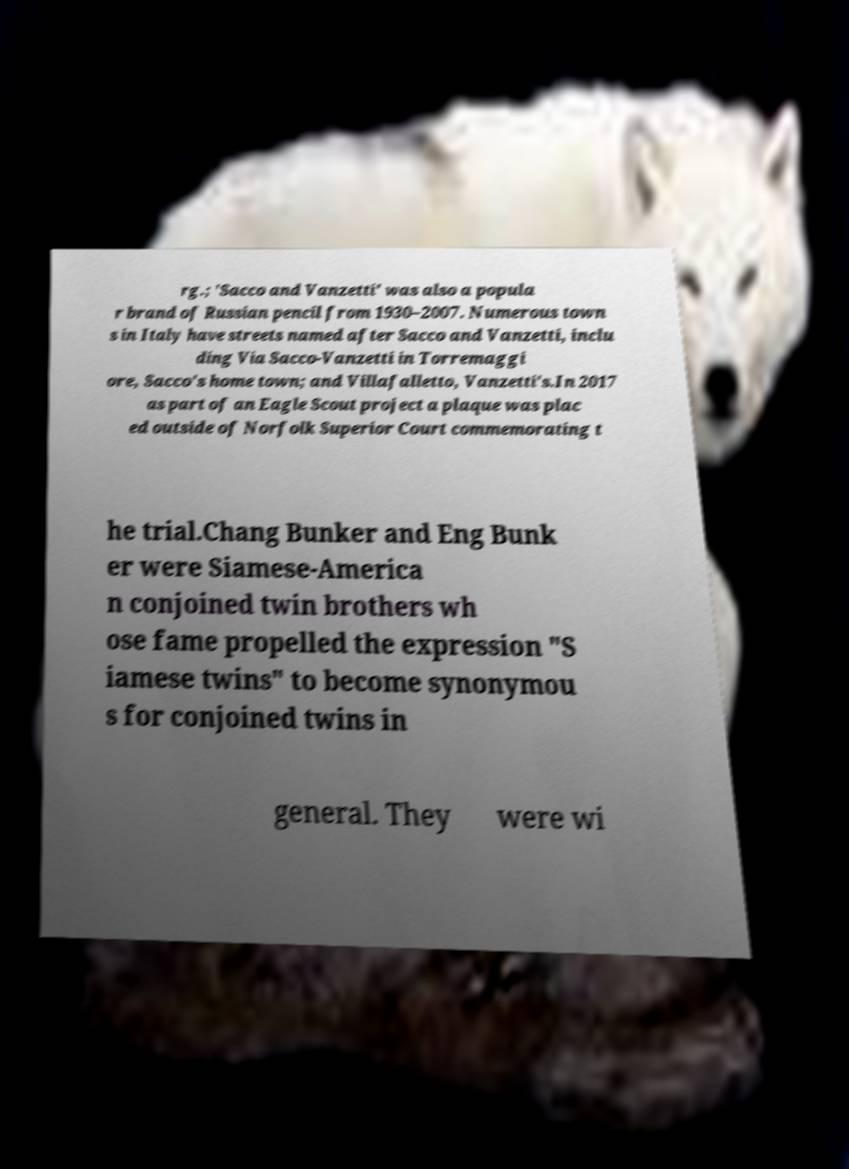Please identify and transcribe the text found in this image. rg.; 'Sacco and Vanzetti' was also a popula r brand of Russian pencil from 1930–2007. Numerous town s in Italy have streets named after Sacco and Vanzetti, inclu ding Via Sacco-Vanzetti in Torremaggi ore, Sacco's home town; and Villafalletto, Vanzetti's.In 2017 as part of an Eagle Scout project a plaque was plac ed outside of Norfolk Superior Court commemorating t he trial.Chang Bunker and Eng Bunk er were Siamese-America n conjoined twin brothers wh ose fame propelled the expression "S iamese twins" to become synonymou s for conjoined twins in general. They were wi 